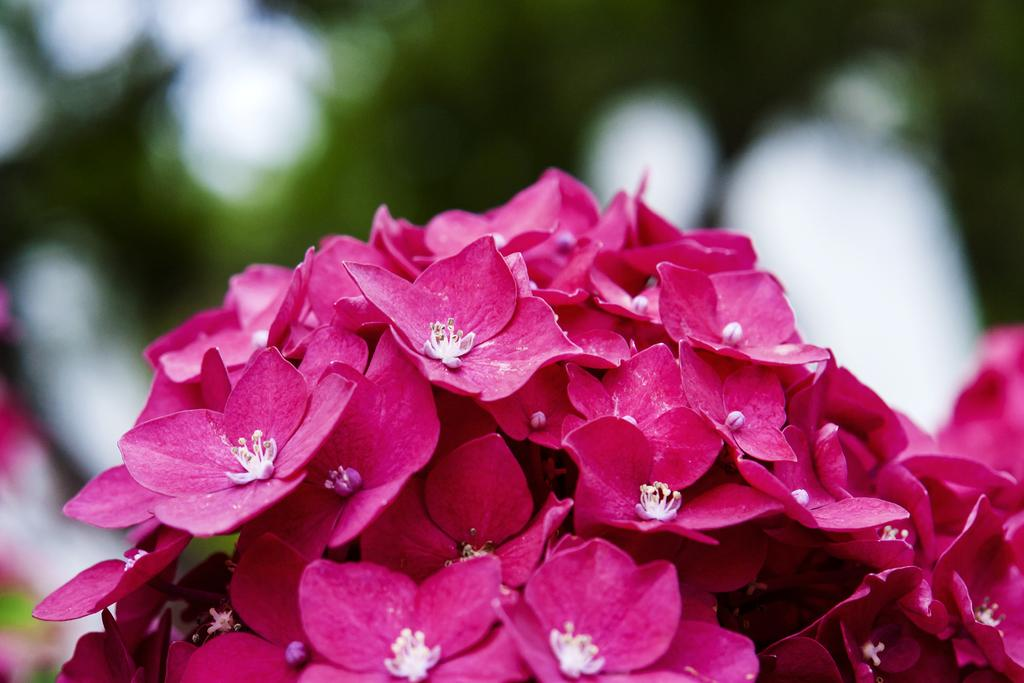What type of objects are present in the image? There are flowers in the image. Can you describe the color of the flowers? The flowers are in pink color. How is the background of the image depicted? The backdrop of the image is blurred. Is there a scarecrow standing among the flowers in the image? No, there is no scarecrow present in the image. Can you tell me the story behind the sink in the image? There is no sink present in the image, so there is no story to tell about it. 